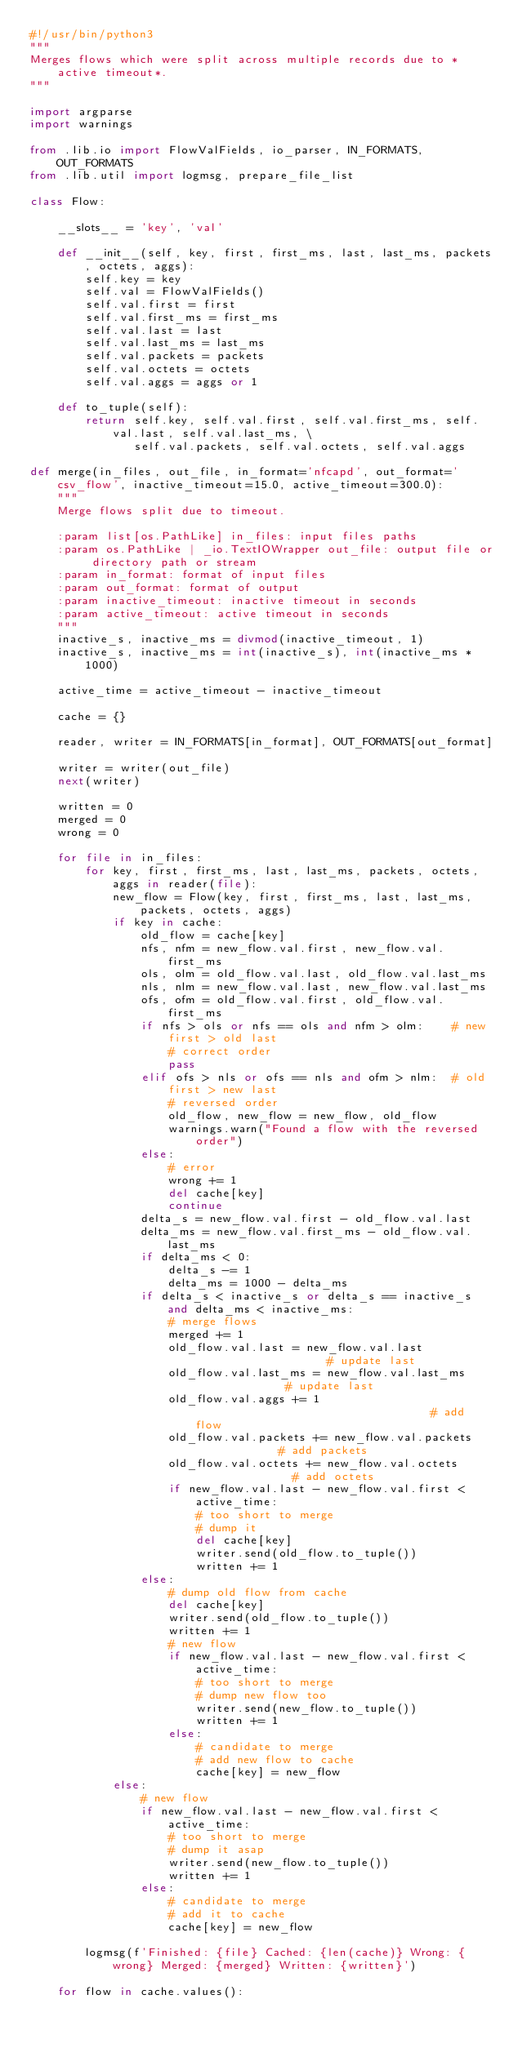Convert code to text. <code><loc_0><loc_0><loc_500><loc_500><_Python_>#!/usr/bin/python3
"""
Merges flows which were split across multiple records due to *active timeout*.
"""

import argparse
import warnings

from .lib.io import FlowValFields, io_parser, IN_FORMATS, OUT_FORMATS
from .lib.util import logmsg, prepare_file_list

class Flow:

    __slots__ = 'key', 'val'

    def __init__(self, key, first, first_ms, last, last_ms, packets, octets, aggs):
        self.key = key
        self.val = FlowValFields()
        self.val.first = first
        self.val.first_ms = first_ms
        self.val.last = last
        self.val.last_ms = last_ms
        self.val.packets = packets
        self.val.octets = octets
        self.val.aggs = aggs or 1

    def to_tuple(self):
        return self.key, self.val.first, self.val.first_ms, self.val.last, self.val.last_ms, \
               self.val.packets, self.val.octets, self.val.aggs

def merge(in_files, out_file, in_format='nfcapd', out_format='csv_flow', inactive_timeout=15.0, active_timeout=300.0):
    """
    Merge flows split due to timeout.

    :param list[os.PathLike] in_files: input files paths
    :param os.PathLike | _io.TextIOWrapper out_file: output file or directory path or stream
    :param in_format: format of input files
    :param out_format: format of output
    :param inactive_timeout: inactive timeout in seconds
    :param active_timeout: active timeout in seconds
    """
    inactive_s, inactive_ms = divmod(inactive_timeout, 1)
    inactive_s, inactive_ms = int(inactive_s), int(inactive_ms * 1000)

    active_time = active_timeout - inactive_timeout

    cache = {}

    reader, writer = IN_FORMATS[in_format], OUT_FORMATS[out_format]

    writer = writer(out_file)
    next(writer)

    written = 0
    merged = 0
    wrong = 0

    for file in in_files:
        for key, first, first_ms, last, last_ms, packets, octets, aggs in reader(file):
            new_flow = Flow(key, first, first_ms, last, last_ms, packets, octets, aggs)
            if key in cache:
                old_flow = cache[key]
                nfs, nfm = new_flow.val.first, new_flow.val.first_ms
                ols, olm = old_flow.val.last, old_flow.val.last_ms
                nls, nlm = new_flow.val.last, new_flow.val.last_ms
                ofs, ofm = old_flow.val.first, old_flow.val.first_ms
                if nfs > ols or nfs == ols and nfm > olm:    # new first > old last
                    # correct order
                    pass
                elif ofs > nls or ofs == nls and ofm > nlm:  # old first > new last
                    # reversed order
                    old_flow, new_flow = new_flow, old_flow
                    warnings.warn("Found a flow with the reversed order")
                else:
                    # error
                    wrong += 1
                    del cache[key]
                    continue
                delta_s = new_flow.val.first - old_flow.val.last
                delta_ms = new_flow.val.first_ms - old_flow.val.last_ms
                if delta_ms < 0:
                    delta_s -= 1
                    delta_ms = 1000 - delta_ms
                if delta_s < inactive_s or delta_s == inactive_s and delta_ms < inactive_ms:
                    # merge flows
                    merged += 1
                    old_flow.val.last = new_flow.val.last                    # update last
                    old_flow.val.last_ms = new_flow.val.last_ms              # update last
                    old_flow.val.aggs += 1                                   # add flow
                    old_flow.val.packets += new_flow.val.packets             # add packets
                    old_flow.val.octets += new_flow.val.octets               # add octets
                    if new_flow.val.last - new_flow.val.first < active_time:
                        # too short to merge
                        # dump it
                        del cache[key]
                        writer.send(old_flow.to_tuple())
                        written += 1
                else:
                    # dump old flow from cache
                    del cache[key]
                    writer.send(old_flow.to_tuple())
                    written += 1
                    # new flow
                    if new_flow.val.last - new_flow.val.first < active_time:
                        # too short to merge
                        # dump new flow too
                        writer.send(new_flow.to_tuple())
                        written += 1
                    else:
                        # candidate to merge
                        # add new flow to cache
                        cache[key] = new_flow
            else:
                # new flow
                if new_flow.val.last - new_flow.val.first < active_time:
                    # too short to merge
                    # dump it asap
                    writer.send(new_flow.to_tuple())
                    written += 1
                else:
                    # candidate to merge
                    # add it to cache
                    cache[key] = new_flow

        logmsg(f'Finished: {file} Cached: {len(cache)} Wrong: {wrong} Merged: {merged} Written: {written}')

    for flow in cache.values():</code> 